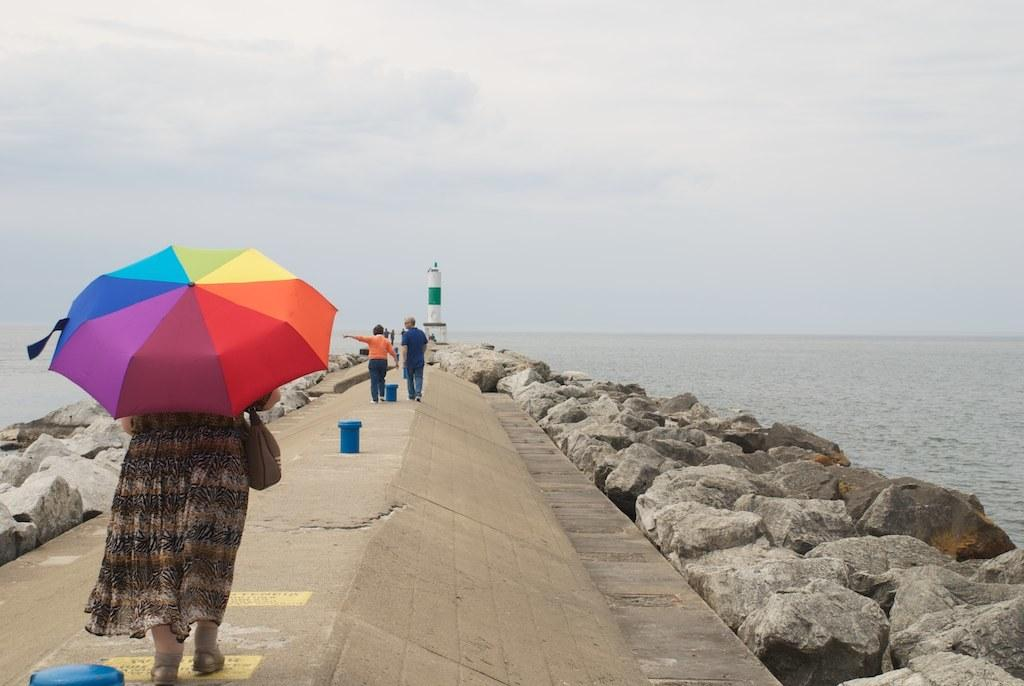What can be seen in the image that people walk on? There is a path in the image that people are walking on. What are the people doing on the path? People are walking on the path. Can you describe the woman with an accessory in the image? One woman is wearing an umbrella. What is visible in the background of the image? There is a sea visible in the background of the image. Are there any bears visible in the image? No, there are no bears present in the image. Can you tell me how many doors are visible in the image? There is no door visible in the image. 